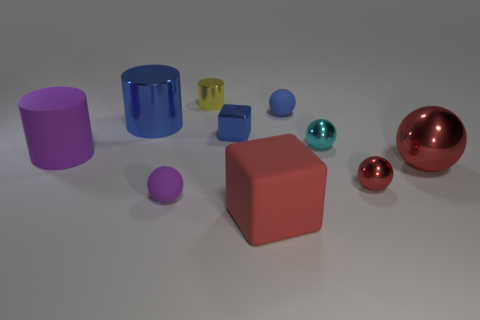Subtract all cyan metallic spheres. How many spheres are left? 4 Subtract all cyan spheres. How many spheres are left? 4 Subtract 2 spheres. How many spheres are left? 3 Subtract all yellow balls. Subtract all cyan cylinders. How many balls are left? 5 Subtract all cylinders. How many objects are left? 7 Add 4 tiny blue spheres. How many tiny blue spheres exist? 5 Subtract 1 purple cylinders. How many objects are left? 9 Subtract all big red rubber objects. Subtract all big red spheres. How many objects are left? 8 Add 6 small red metal objects. How many small red metal objects are left? 7 